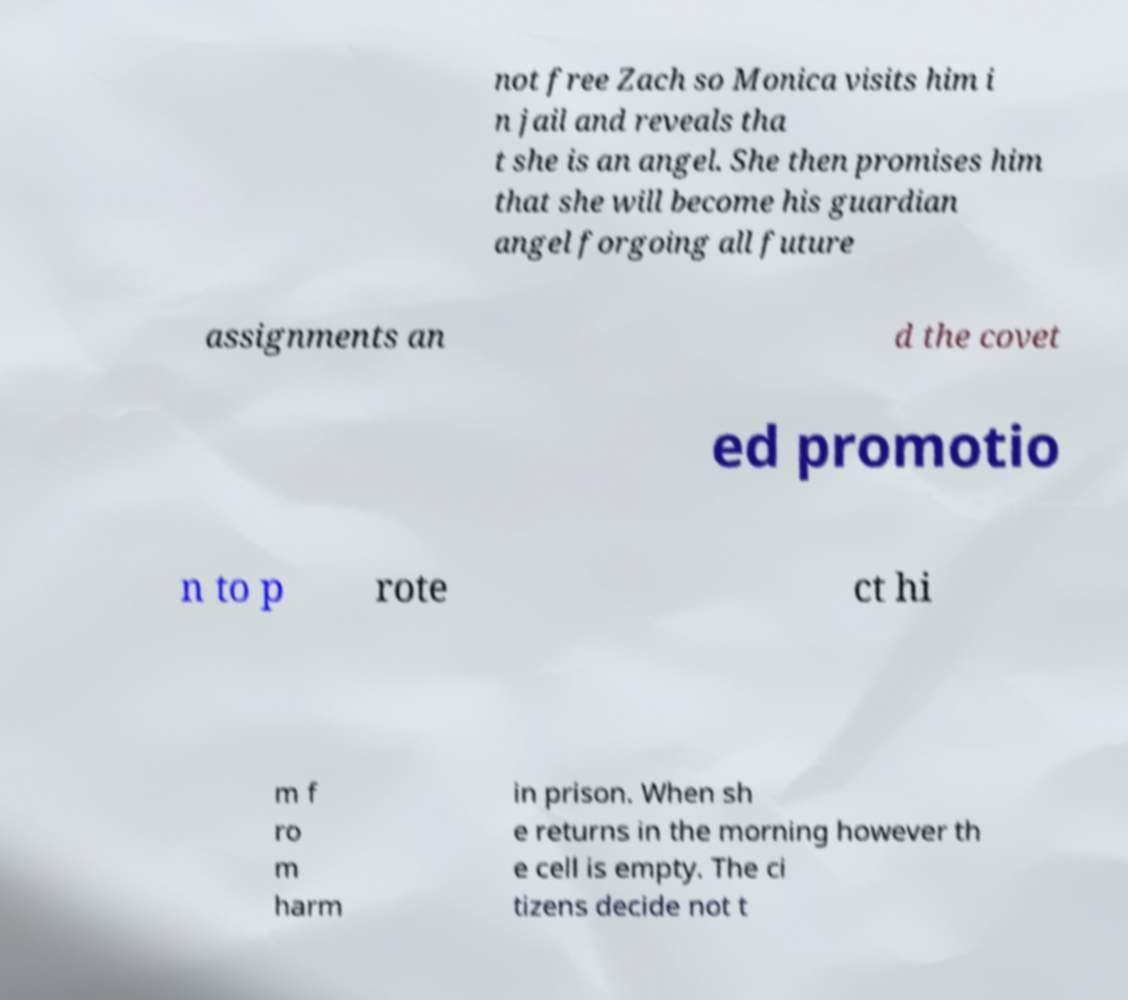Can you accurately transcribe the text from the provided image for me? not free Zach so Monica visits him i n jail and reveals tha t she is an angel. She then promises him that she will become his guardian angel forgoing all future assignments an d the covet ed promotio n to p rote ct hi m f ro m harm in prison. When sh e returns in the morning however th e cell is empty. The ci tizens decide not t 